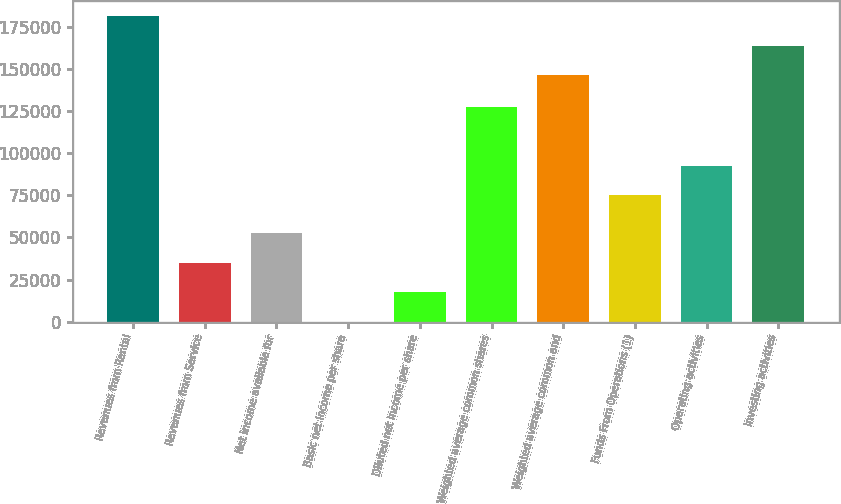Convert chart to OTSL. <chart><loc_0><loc_0><loc_500><loc_500><bar_chart><fcel>Revenues from Rental<fcel>Revenues from Service<fcel>Net income available for<fcel>Basic net income per share<fcel>Diluted net income per share<fcel>Weighted average common shares<fcel>Weighted average common and<fcel>Funds From Operations (1)<fcel>Operating activities<fcel>Investing activities<nl><fcel>181273<fcel>34947.1<fcel>52420.5<fcel>0.39<fcel>17473.8<fcel>127450<fcel>146326<fcel>75030<fcel>92503.4<fcel>163799<nl></chart> 